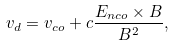<formula> <loc_0><loc_0><loc_500><loc_500>v _ { d } = v _ { c o } + c \frac { E _ { n c o } \times B } { B ^ { 2 } } ,</formula> 